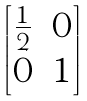Convert formula to latex. <formula><loc_0><loc_0><loc_500><loc_500>\begin{bmatrix} \frac { 1 } { 2 } & 0 \\ 0 & 1 \end{bmatrix}</formula> 